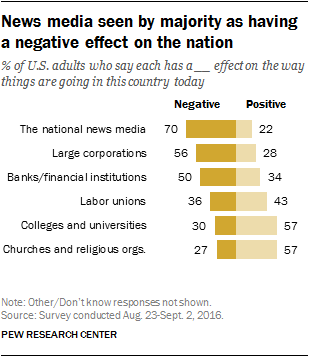Identify some key points in this picture. The color bar denoted yellow, and it was negative. The total value of all yellow bars is 269. 